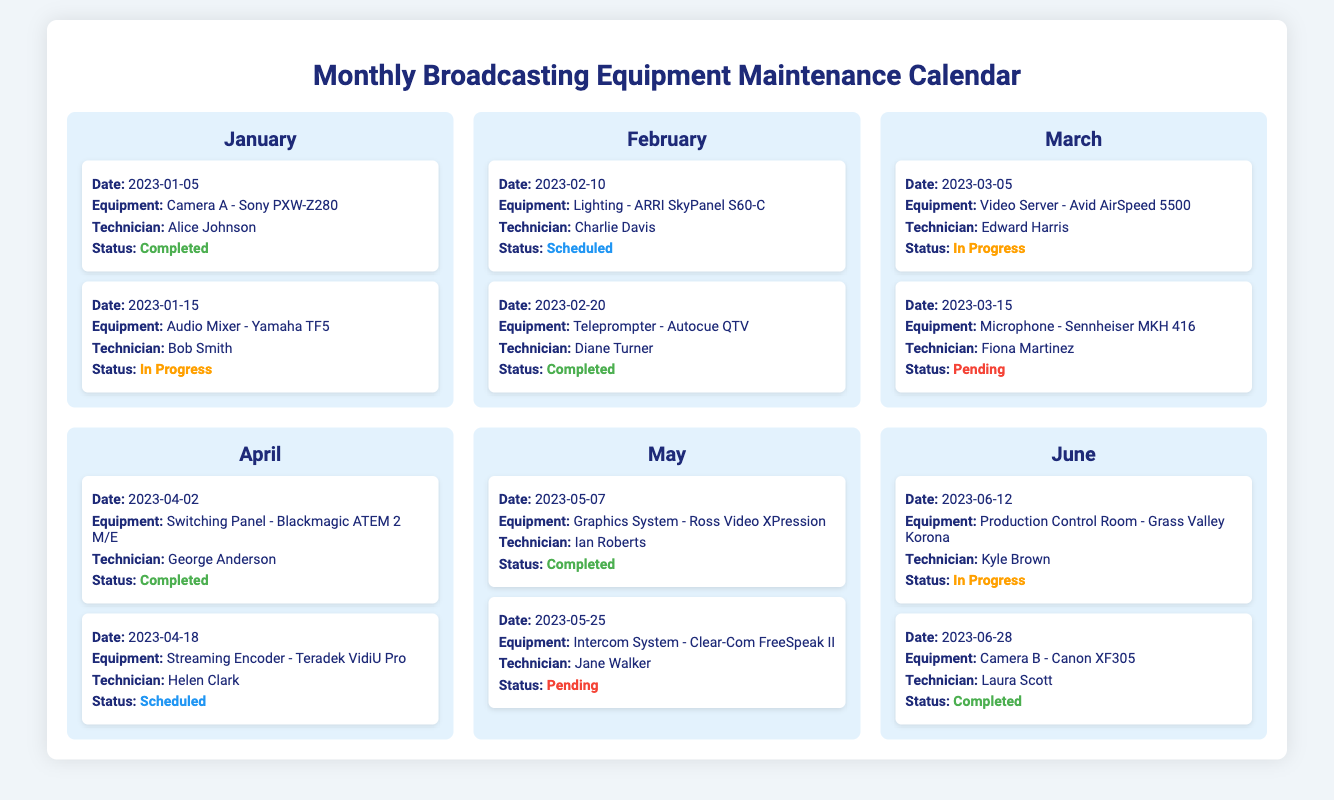What is the equipment maintained on January 5th? The document lists the equipment maintained on January 5th as Camera A - Sony PXW-Z280.
Answer: Camera A - Sony PXW-Z280 Who was the technician for the Audio Mixer in January? The technician assigned to the Audio Mixer - Yamaha TF5 maintenance in January was Bob Smith.
Answer: Bob Smith What is the status of the maintenance for Teleprompter in February? The Teleprompter - Autocue QTV maintenance is marked as Completed.
Answer: Completed How many pieces of equipment were scheduled in April? The document indicates there were two maintenance items scheduled in April.
Answer: 2 Which month has the most 'In Progress' statuses? The document shows that March has the most 'In Progress' statuses, with two instances listed.
Answer: March What is the last recorded maintenance date in the document? The last recorded maintenance date in the document is June 28, 2023, for Camera B - Canon XF305.
Answer: June 28, 2023 What equipment is scheduled for maintenance in May? The maintenance scheduled for May includes the Intercom System - Clear-Com FreeSpeak II on May 25th.
Answer: Intercom System - Clear-Com FreeSpeak II Who was responsible for the Camera B maintenance in June? The technician responsible for the maintenance of Camera B - Canon XF305 was Laura Scott.
Answer: Laura Scott 